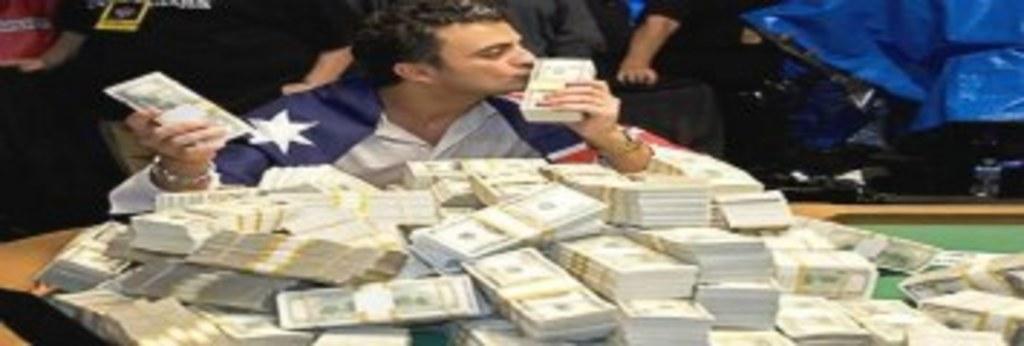In one or two sentences, can you explain what this image depicts? In this image we can see a group of people. One person is holding bundles in his hand. At the bottom of the image we can see group of currency bundles placed on the surface. At the top right corner of the image we can see a cover. 